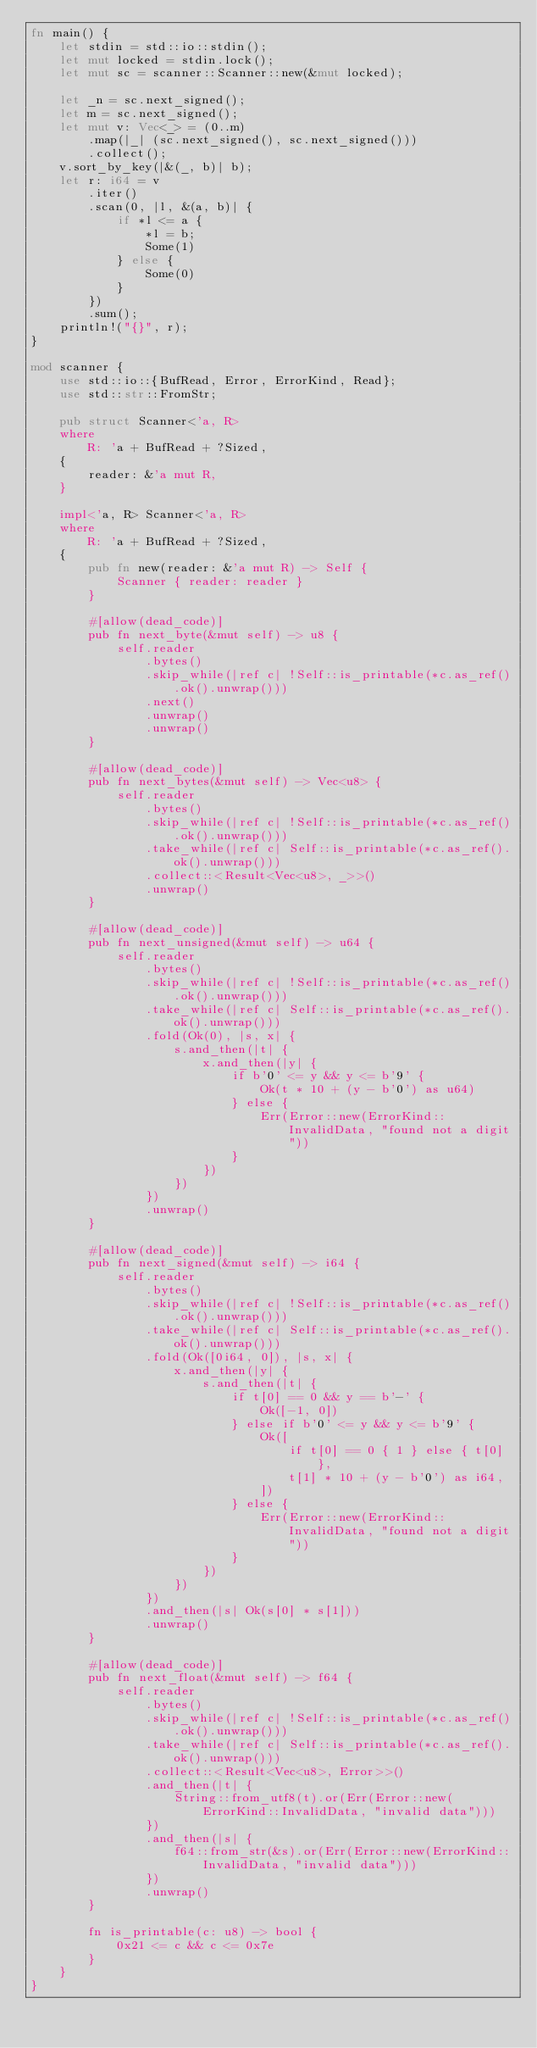<code> <loc_0><loc_0><loc_500><loc_500><_Rust_>fn main() {
    let stdin = std::io::stdin();
    let mut locked = stdin.lock();
    let mut sc = scanner::Scanner::new(&mut locked);

    let _n = sc.next_signed();
    let m = sc.next_signed();
    let mut v: Vec<_> = (0..m)
        .map(|_| (sc.next_signed(), sc.next_signed()))
        .collect();
    v.sort_by_key(|&(_, b)| b);
    let r: i64 = v
        .iter()
        .scan(0, |l, &(a, b)| {
            if *l <= a {
                *l = b;
                Some(1)
            } else {
                Some(0)
            }
        })
        .sum();
    println!("{}", r);
}

mod scanner {
    use std::io::{BufRead, Error, ErrorKind, Read};
    use std::str::FromStr;

    pub struct Scanner<'a, R>
    where
        R: 'a + BufRead + ?Sized,
    {
        reader: &'a mut R,
    }

    impl<'a, R> Scanner<'a, R>
    where
        R: 'a + BufRead + ?Sized,
    {
        pub fn new(reader: &'a mut R) -> Self {
            Scanner { reader: reader }
        }

        #[allow(dead_code)]
        pub fn next_byte(&mut self) -> u8 {
            self.reader
                .bytes()
                .skip_while(|ref c| !Self::is_printable(*c.as_ref().ok().unwrap()))
                .next()
                .unwrap()
                .unwrap()
        }

        #[allow(dead_code)]
        pub fn next_bytes(&mut self) -> Vec<u8> {
            self.reader
                .bytes()
                .skip_while(|ref c| !Self::is_printable(*c.as_ref().ok().unwrap()))
                .take_while(|ref c| Self::is_printable(*c.as_ref().ok().unwrap()))
                .collect::<Result<Vec<u8>, _>>()
                .unwrap()
        }

        #[allow(dead_code)]
        pub fn next_unsigned(&mut self) -> u64 {
            self.reader
                .bytes()
                .skip_while(|ref c| !Self::is_printable(*c.as_ref().ok().unwrap()))
                .take_while(|ref c| Self::is_printable(*c.as_ref().ok().unwrap()))
                .fold(Ok(0), |s, x| {
                    s.and_then(|t| {
                        x.and_then(|y| {
                            if b'0' <= y && y <= b'9' {
                                Ok(t * 10 + (y - b'0') as u64)
                            } else {
                                Err(Error::new(ErrorKind::InvalidData, "found not a digit"))
                            }
                        })
                    })
                })
                .unwrap()
        }

        #[allow(dead_code)]
        pub fn next_signed(&mut self) -> i64 {
            self.reader
                .bytes()
                .skip_while(|ref c| !Self::is_printable(*c.as_ref().ok().unwrap()))
                .take_while(|ref c| Self::is_printable(*c.as_ref().ok().unwrap()))
                .fold(Ok([0i64, 0]), |s, x| {
                    x.and_then(|y| {
                        s.and_then(|t| {
                            if t[0] == 0 && y == b'-' {
                                Ok([-1, 0])
                            } else if b'0' <= y && y <= b'9' {
                                Ok([
                                    if t[0] == 0 { 1 } else { t[0] },
                                    t[1] * 10 + (y - b'0') as i64,
                                ])
                            } else {
                                Err(Error::new(ErrorKind::InvalidData, "found not a digit"))
                            }
                        })
                    })
                })
                .and_then(|s| Ok(s[0] * s[1]))
                .unwrap()
        }

        #[allow(dead_code)]
        pub fn next_float(&mut self) -> f64 {
            self.reader
                .bytes()
                .skip_while(|ref c| !Self::is_printable(*c.as_ref().ok().unwrap()))
                .take_while(|ref c| Self::is_printable(*c.as_ref().ok().unwrap()))
                .collect::<Result<Vec<u8>, Error>>()
                .and_then(|t| {
                    String::from_utf8(t).or(Err(Error::new(ErrorKind::InvalidData, "invalid data")))
                })
                .and_then(|s| {
                    f64::from_str(&s).or(Err(Error::new(ErrorKind::InvalidData, "invalid data")))
                })
                .unwrap()
        }

        fn is_printable(c: u8) -> bool {
            0x21 <= c && c <= 0x7e
        }
    }
}
</code> 